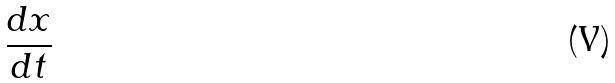Convert formula to latex. <formula><loc_0><loc_0><loc_500><loc_500>\frac { d x } { d t }</formula> 